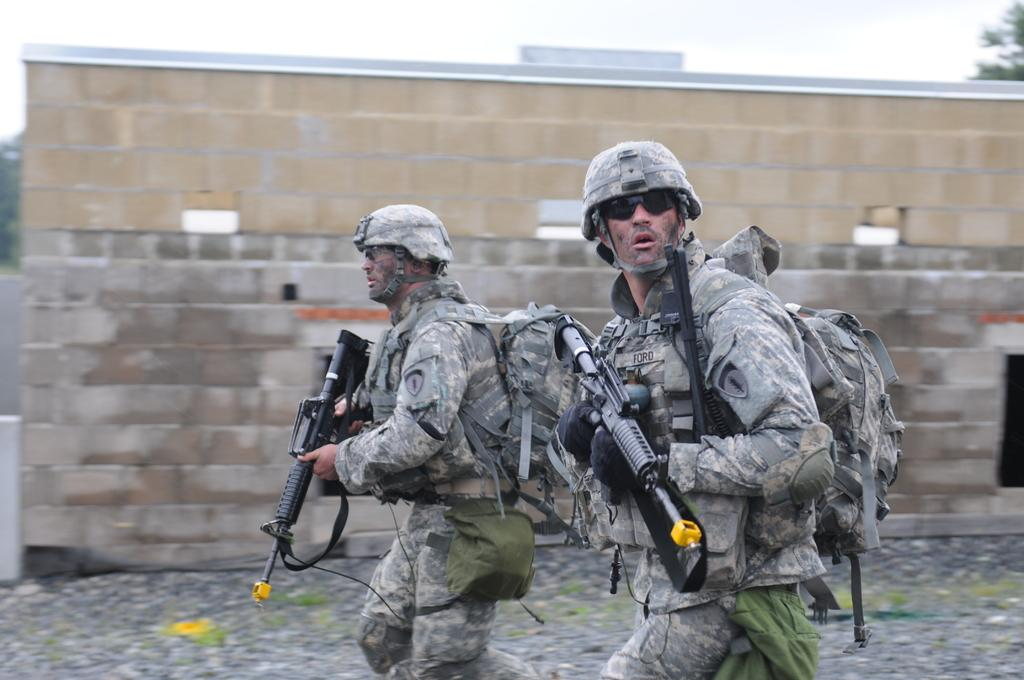How many people are in the image? There are two men in the image. What are the men holding in the image? The men are holding guns in the image. Where are the men standing in the image? They are standing on a road in the image. What can be seen in the background of the image? There is a wall and the sky visible in the background of the image. What type of toy can be seen on the roof in the image? There is no toy or roof present in the image. Is there a note attached to the wall in the image? There is no note mentioned in the provided facts, so we cannot determine if there is one in the image. 